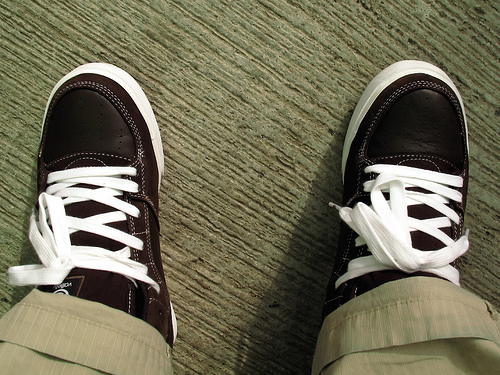<image>
Can you confirm if the floor is on the shoe laces? No. The floor is not positioned on the shoe laces. They may be near each other, but the floor is not supported by or resting on top of the shoe laces. 